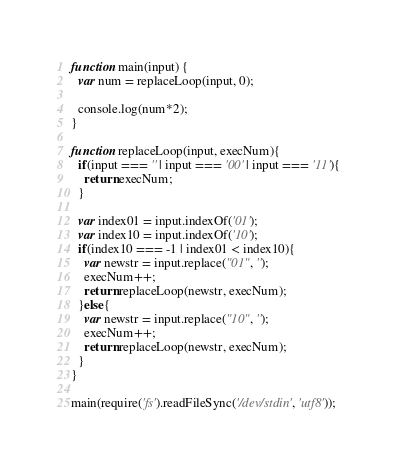<code> <loc_0><loc_0><loc_500><loc_500><_JavaScript_>function main(input) {
  var num = replaceLoop(input, 0);

  console.log(num*2);
}

function replaceLoop(input, execNum){
  if(input === '' | input === '00' | input === '11'){
    return execNum;
  }

  var index01 = input.indexOf('01');
  var index10 = input.indexOf('10');
  if(index10 === -1 | index01 < index10){
    var newstr = input.replace("01", '');
    execNum++;
    return replaceLoop(newstr, execNum);
  }else{
    var newstr = input.replace("10", '');
    execNum++;
    return replaceLoop(newstr, execNum);
  }
}

main(require('fs').readFileSync('/dev/stdin', 'utf8'));
</code> 